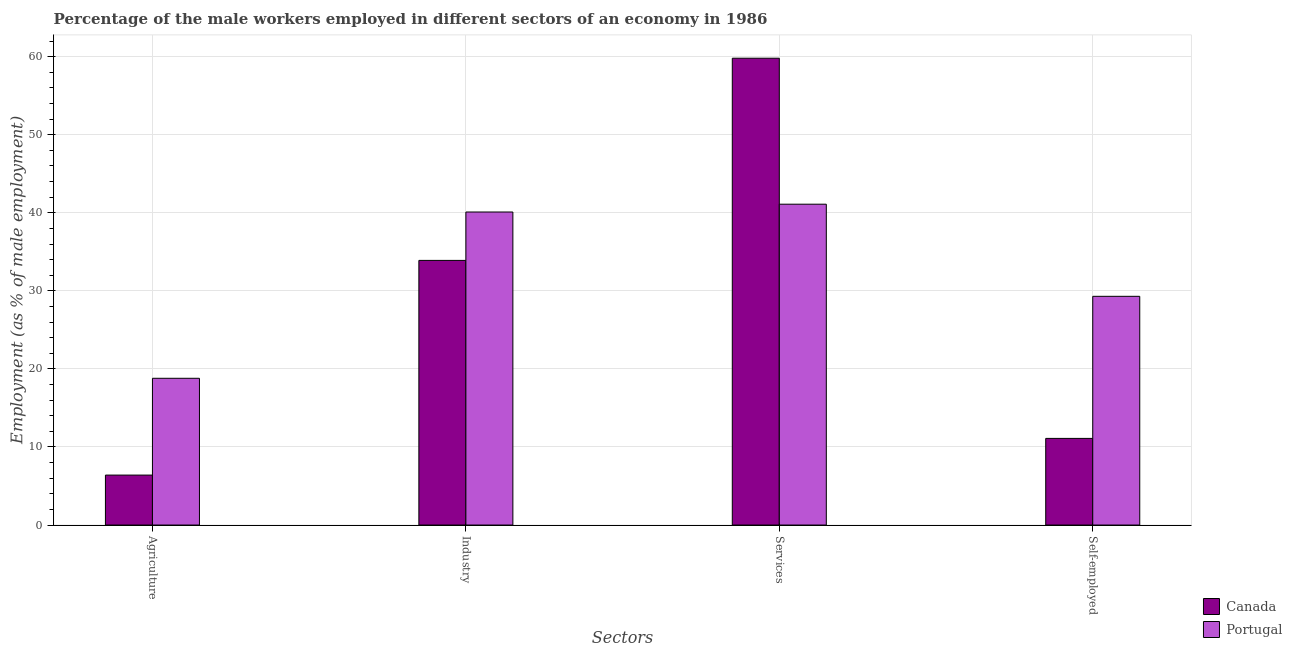Are the number of bars on each tick of the X-axis equal?
Your response must be concise. Yes. How many bars are there on the 3rd tick from the left?
Your answer should be compact. 2. How many bars are there on the 1st tick from the right?
Ensure brevity in your answer.  2. What is the label of the 1st group of bars from the left?
Ensure brevity in your answer.  Agriculture. What is the percentage of male workers in services in Canada?
Provide a succinct answer. 59.8. Across all countries, what is the maximum percentage of self employed male workers?
Your answer should be very brief. 29.3. Across all countries, what is the minimum percentage of male workers in services?
Offer a very short reply. 41.1. In which country was the percentage of self employed male workers minimum?
Your response must be concise. Canada. What is the total percentage of self employed male workers in the graph?
Provide a short and direct response. 40.4. What is the difference between the percentage of male workers in services in Canada and that in Portugal?
Ensure brevity in your answer.  18.7. What is the difference between the percentage of male workers in industry in Canada and the percentage of self employed male workers in Portugal?
Your response must be concise. 4.6. What is the average percentage of male workers in agriculture per country?
Your answer should be compact. 12.6. What is the difference between the percentage of male workers in services and percentage of self employed male workers in Canada?
Make the answer very short. 48.7. What is the ratio of the percentage of self employed male workers in Canada to that in Portugal?
Your answer should be very brief. 0.38. What is the difference between the highest and the second highest percentage of male workers in services?
Your answer should be compact. 18.7. What is the difference between the highest and the lowest percentage of male workers in services?
Your response must be concise. 18.7. Is the sum of the percentage of male workers in agriculture in Canada and Portugal greater than the maximum percentage of male workers in industry across all countries?
Make the answer very short. No. Is it the case that in every country, the sum of the percentage of male workers in agriculture and percentage of self employed male workers is greater than the sum of percentage of male workers in industry and percentage of male workers in services?
Offer a terse response. No. What does the 1st bar from the right in Services represents?
Ensure brevity in your answer.  Portugal. Is it the case that in every country, the sum of the percentage of male workers in agriculture and percentage of male workers in industry is greater than the percentage of male workers in services?
Provide a succinct answer. No. How many bars are there?
Your response must be concise. 8. Are all the bars in the graph horizontal?
Your response must be concise. No. What is the difference between two consecutive major ticks on the Y-axis?
Keep it short and to the point. 10. Does the graph contain grids?
Provide a succinct answer. Yes. Where does the legend appear in the graph?
Your response must be concise. Bottom right. How many legend labels are there?
Ensure brevity in your answer.  2. How are the legend labels stacked?
Your response must be concise. Vertical. What is the title of the graph?
Provide a short and direct response. Percentage of the male workers employed in different sectors of an economy in 1986. What is the label or title of the X-axis?
Offer a very short reply. Sectors. What is the label or title of the Y-axis?
Offer a very short reply. Employment (as % of male employment). What is the Employment (as % of male employment) in Canada in Agriculture?
Your answer should be compact. 6.4. What is the Employment (as % of male employment) in Portugal in Agriculture?
Make the answer very short. 18.8. What is the Employment (as % of male employment) in Canada in Industry?
Offer a very short reply. 33.9. What is the Employment (as % of male employment) of Portugal in Industry?
Your answer should be very brief. 40.1. What is the Employment (as % of male employment) in Canada in Services?
Your answer should be very brief. 59.8. What is the Employment (as % of male employment) of Portugal in Services?
Offer a very short reply. 41.1. What is the Employment (as % of male employment) of Canada in Self-employed?
Provide a succinct answer. 11.1. What is the Employment (as % of male employment) of Portugal in Self-employed?
Offer a very short reply. 29.3. Across all Sectors, what is the maximum Employment (as % of male employment) of Canada?
Provide a succinct answer. 59.8. Across all Sectors, what is the maximum Employment (as % of male employment) in Portugal?
Make the answer very short. 41.1. Across all Sectors, what is the minimum Employment (as % of male employment) of Canada?
Give a very brief answer. 6.4. Across all Sectors, what is the minimum Employment (as % of male employment) in Portugal?
Provide a succinct answer. 18.8. What is the total Employment (as % of male employment) of Canada in the graph?
Provide a succinct answer. 111.2. What is the total Employment (as % of male employment) of Portugal in the graph?
Ensure brevity in your answer.  129.3. What is the difference between the Employment (as % of male employment) in Canada in Agriculture and that in Industry?
Give a very brief answer. -27.5. What is the difference between the Employment (as % of male employment) of Portugal in Agriculture and that in Industry?
Your answer should be very brief. -21.3. What is the difference between the Employment (as % of male employment) in Canada in Agriculture and that in Services?
Make the answer very short. -53.4. What is the difference between the Employment (as % of male employment) of Portugal in Agriculture and that in Services?
Keep it short and to the point. -22.3. What is the difference between the Employment (as % of male employment) of Canada in Industry and that in Services?
Give a very brief answer. -25.9. What is the difference between the Employment (as % of male employment) of Canada in Industry and that in Self-employed?
Offer a terse response. 22.8. What is the difference between the Employment (as % of male employment) in Portugal in Industry and that in Self-employed?
Your answer should be very brief. 10.8. What is the difference between the Employment (as % of male employment) of Canada in Services and that in Self-employed?
Offer a very short reply. 48.7. What is the difference between the Employment (as % of male employment) of Portugal in Services and that in Self-employed?
Your answer should be very brief. 11.8. What is the difference between the Employment (as % of male employment) of Canada in Agriculture and the Employment (as % of male employment) of Portugal in Industry?
Provide a succinct answer. -33.7. What is the difference between the Employment (as % of male employment) of Canada in Agriculture and the Employment (as % of male employment) of Portugal in Services?
Keep it short and to the point. -34.7. What is the difference between the Employment (as % of male employment) of Canada in Agriculture and the Employment (as % of male employment) of Portugal in Self-employed?
Offer a very short reply. -22.9. What is the difference between the Employment (as % of male employment) in Canada in Services and the Employment (as % of male employment) in Portugal in Self-employed?
Provide a short and direct response. 30.5. What is the average Employment (as % of male employment) in Canada per Sectors?
Offer a very short reply. 27.8. What is the average Employment (as % of male employment) of Portugal per Sectors?
Ensure brevity in your answer.  32.33. What is the difference between the Employment (as % of male employment) in Canada and Employment (as % of male employment) in Portugal in Agriculture?
Make the answer very short. -12.4. What is the difference between the Employment (as % of male employment) of Canada and Employment (as % of male employment) of Portugal in Self-employed?
Provide a short and direct response. -18.2. What is the ratio of the Employment (as % of male employment) in Canada in Agriculture to that in Industry?
Ensure brevity in your answer.  0.19. What is the ratio of the Employment (as % of male employment) in Portugal in Agriculture to that in Industry?
Keep it short and to the point. 0.47. What is the ratio of the Employment (as % of male employment) of Canada in Agriculture to that in Services?
Give a very brief answer. 0.11. What is the ratio of the Employment (as % of male employment) of Portugal in Agriculture to that in Services?
Offer a very short reply. 0.46. What is the ratio of the Employment (as % of male employment) of Canada in Agriculture to that in Self-employed?
Provide a short and direct response. 0.58. What is the ratio of the Employment (as % of male employment) of Portugal in Agriculture to that in Self-employed?
Keep it short and to the point. 0.64. What is the ratio of the Employment (as % of male employment) in Canada in Industry to that in Services?
Your response must be concise. 0.57. What is the ratio of the Employment (as % of male employment) in Portugal in Industry to that in Services?
Your answer should be very brief. 0.98. What is the ratio of the Employment (as % of male employment) of Canada in Industry to that in Self-employed?
Your response must be concise. 3.05. What is the ratio of the Employment (as % of male employment) in Portugal in Industry to that in Self-employed?
Ensure brevity in your answer.  1.37. What is the ratio of the Employment (as % of male employment) of Canada in Services to that in Self-employed?
Your response must be concise. 5.39. What is the ratio of the Employment (as % of male employment) of Portugal in Services to that in Self-employed?
Your response must be concise. 1.4. What is the difference between the highest and the second highest Employment (as % of male employment) of Canada?
Offer a terse response. 25.9. What is the difference between the highest and the second highest Employment (as % of male employment) of Portugal?
Keep it short and to the point. 1. What is the difference between the highest and the lowest Employment (as % of male employment) in Canada?
Your answer should be compact. 53.4. What is the difference between the highest and the lowest Employment (as % of male employment) of Portugal?
Your answer should be compact. 22.3. 